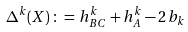Convert formula to latex. <formula><loc_0><loc_0><loc_500><loc_500>\Delta ^ { k } ( X ) \, \colon = \, h ^ { k } _ { B C } + h ^ { k } _ { A } - 2 \, b _ { k }</formula> 